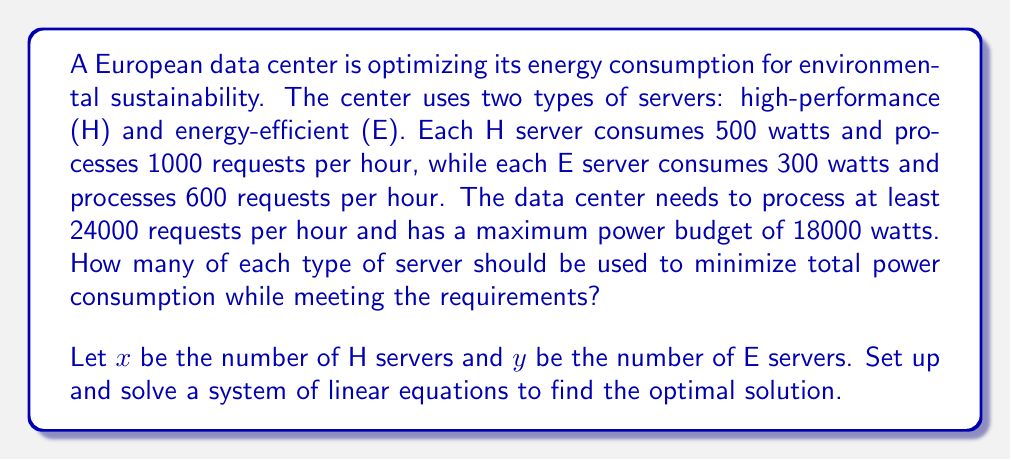Can you answer this question? Let's approach this step-by-step:

1) First, we need to set up our constraints based on the given information:

   a) Request processing constraint:
      $$1000x + 600y \geq 24000$$

   b) Power consumption constraint:
      $$500x + 300y \leq 18000$$

2) Our objective is to minimize the total power consumption, which is represented by:
   $$500x + 300y$$

3) To solve this system, we can use the method of elimination:

   Multiply the first equation by 3 and the second by 5:
   $$3000x + 1800y \geq 72000$$
   $$2500x + 1500y \leq 90000$$

4) Subtracting the second equation from the first:
   $$500x + 300y = 18000$$

5) This equation represents the maximum power usage. To minimize power consumption, we need to find the smallest values of $x$ and $y$ that satisfy both this equation and the request processing constraint.

6) Solving for $x$ in terms of $y$:
   $$x = 36 - \frac{3}{5}y$$

7) Substituting this into the request processing constraint:
   $$1000(36 - \frac{3}{5}y) + 600y \geq 24000$$
   $$36000 - 600y + 600y \geq 24000$$
   $$36000 \geq 24000$$

8) This inequality is always true for non-negative $y$, so our solution will be determined by the power consumption equation.

9) To find the integer solution that minimizes power consumption, we can try values:
   For $y = 30$, $x = 36 - \frac{3}{5}(30) = 18$
   This satisfies both constraints and uses all available power.

Therefore, the optimal solution is to use 18 high-performance servers and 30 energy-efficient servers.
Answer: 18 high-performance servers, 30 energy-efficient servers 